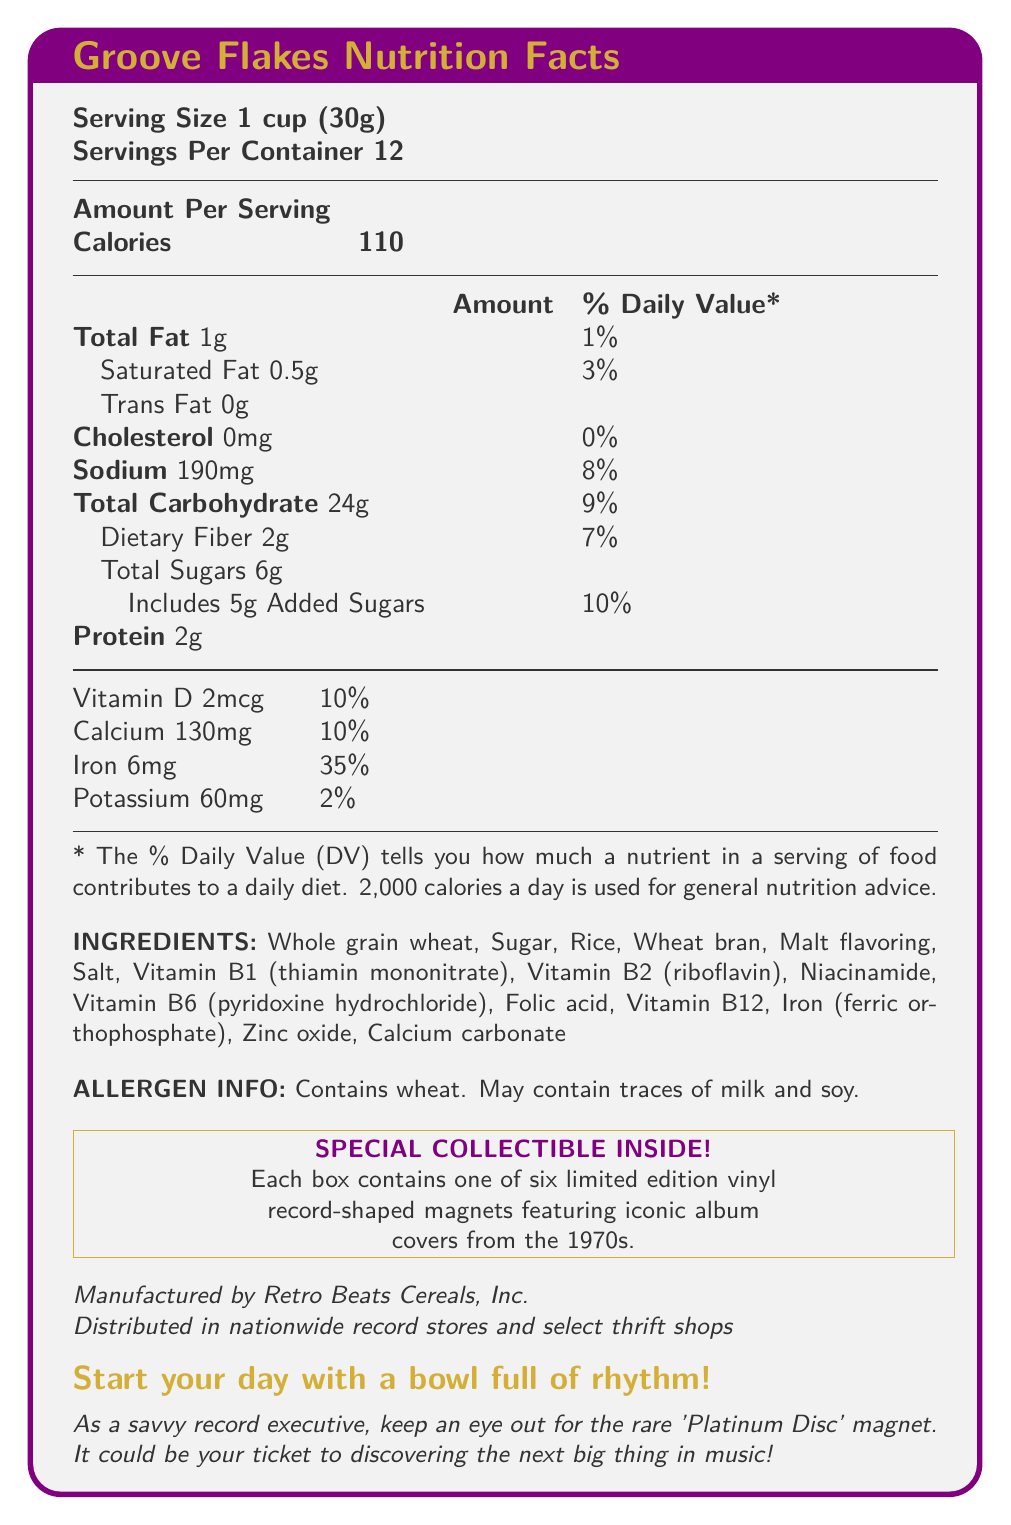what is the serving size? The document clearly states the serving size as "1 cup (30g)".
Answer: 1 cup (30g) how many servings are in the container? The document mentions "Servings Per Container: 12".
Answer: 12 how many calories are there per serving? The document lists calories per serving as 110.
Answer: 110 how much total fat is in a serving? The document shows total fat per serving as 1g.
Answer: 1g what percentage of the daily value is the sodium content? The document states that the daily value percentage for sodium is 8%.
Answer: 8% how many grams of added sugars does each serving contain? The document specifies that added sugars per serving are 5g.
Answer: 5g what is the amount of iron per serving and its percentage of the daily value? The document indicates that iron content per serving is 6mg, which is 35% of the daily value.
Answer: 6mg, 35% which following vitamin is present in the highest percentage of daily value? A. Vitamin D B. Vitamin B6 C. Folic Acid D. Vitamin B12 The document lists Vitamin D with a daily value of 10%, which is the highest percentage among the given options.
Answer: A. Vitamin D which of these is NOT listed as an ingredient? A. Rice B. Milk C. Malt flavoring D. Vitamin B2 The list of ingredients does not include milk, though the allergen info states it may contain traces of milk.
Answer: B. Milk does the product contain trans fat? The document states the amount of trans fat as 0g.
Answer: No is there any cholesterol in the cereal? The document indicates that there is 0mg of cholesterol.
Answer: No what is the marketing tagline for Groove Flakes? The document includes a bold tagline: "Start your day with a bowl full of rhythm!"
Answer: Start your day with a bowl full of rhythm! summarize the nutrition facts and special features of Groove Flakes cereal. This summary captures the essential nutritional information, ingredients, allergen info, special collectible feature, manufacturer, and distribution details.
Answer: Groove Flakes cereal has a serving size of 1 cup (30g) with 12 servings per container. Each serving contains 110 calories, 1g of total fat, 0.5g of saturated fat, and 0g of trans fat. It has 0mg cholesterol, 190mg sodium (8% daily value), 24g of total carbohydrate (9% daily value) including 2g of dietary fiber (7% daily value) and 6g of total sugars (5g of which are added sugars, 10% daily value). It contains 2g of protein and is fortified with vitamins and minerals including Vitamin D (2mcg, 10% daily value), Calcium (130mg, 10% daily value), Iron (6mg, 35% daily value), and Potassium (60mg, 2% daily value). Ingredients include whole grain wheat, sugar, rice, wheat bran, and various vitamins and minerals. The product contains wheat and may contain traces of milk and soy. Each box includes one of six limited edition vinyl record-shaped magnets featuring iconic 1970s album covers, with a rare 'Platinum Disc' magnet noted as special. The product is manufactured by Retro Beats Cereals, Inc. and available at nationwide record stores and select thrift shops. what is the total carbohydrate content per serving? The document states that the total carbohydrate content per serving is 24g.
Answer: 24g what special collectible is included in each box of Groove Flakes? The document clearly states that each box contains one of these collectibles.
Answer: One of six limited edition vinyl record-shaped magnets featuring iconic album covers from the 1970s. which company manufactures Groove Flakes? The document mentions that Groove Flakes is manufactured by Retro Beats Cereals, Inc.
Answer: Retro Beats Cereals, Inc. where is the product distributed? The document indicates that the product is distributed in nationwide record stores and select thrift shops.
Answer: Nationwide record stores and select thrift shops what are the first three ingredients listed? The document lists ingredients in the order of predominance, with the first three being Whole grain wheat, Sugar, and Rice.
Answer: Whole grain wheat, Sugar, Rice how much protein is in one serving of Groove Flakes? The document states that there are 2g of protein per serving.
Answer: 2g is there a way to determine the price of Groove Flakes cereal from the document? The document does not provide any information regarding the price of the Groove Flakes cereal.
Answer: Not enough information what is the amount of Vitamin D in each serving? The document specifies that each serving contains 2mcg of Vitamin D.
Answer: 2mcg what trace allergens may Groove Flakes contain? The document notes that while the product contains wheat, it may also contain traces of milk and soy.
Answer: Milk and soy if I consume two servings of Groove Flakes, how many calories will I have eaten? Each serving contains 110 calories, so consuming two servings would result in 2 * 110 = 220 calories.
Answer: 220 calories 